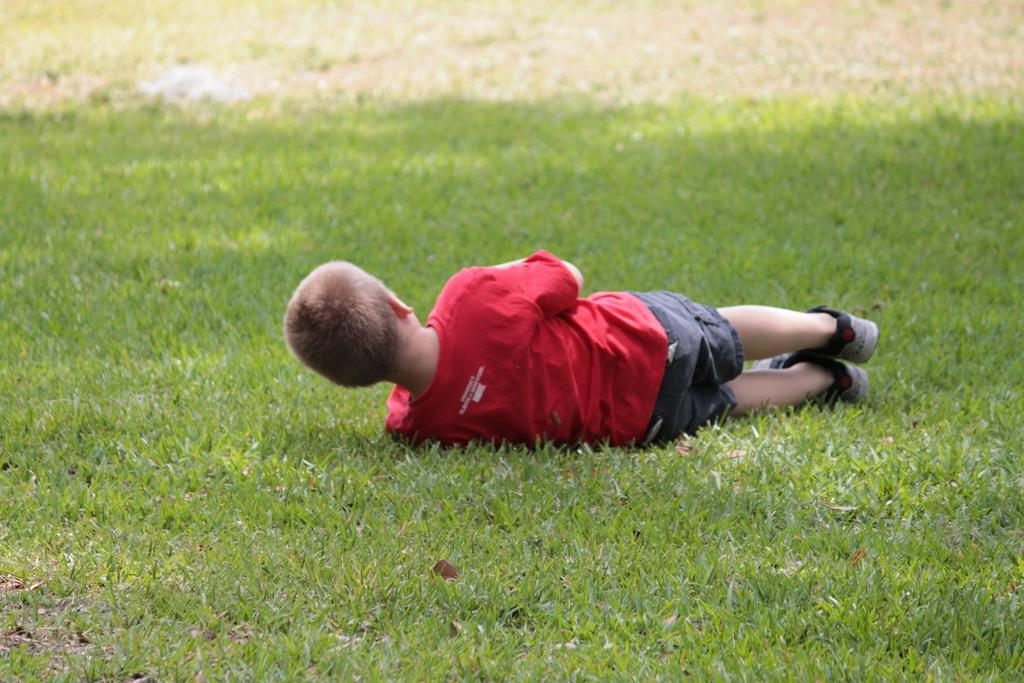Who is the main subject in the image? There is a boy in the image. What is the boy doing in the image? The boy is lying on the grass. What type of punishment is the boy receiving in the image? There is no indication of punishment in the image; the boy is simply lying on the grass. What kind of rice is being cooked in the image? There is no rice or cooking activity present in the image. 